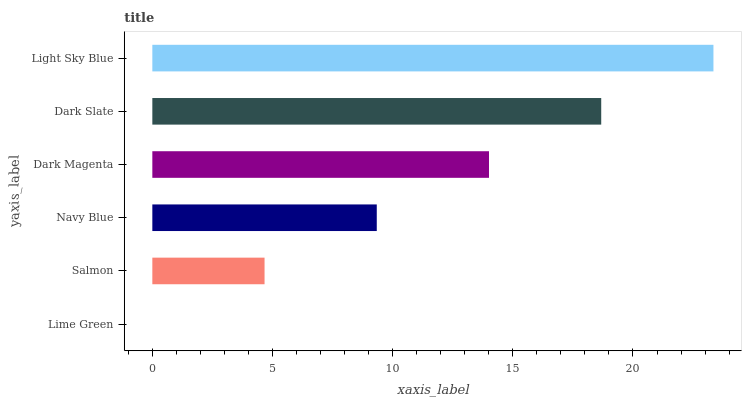Is Lime Green the minimum?
Answer yes or no. Yes. Is Light Sky Blue the maximum?
Answer yes or no. Yes. Is Salmon the minimum?
Answer yes or no. No. Is Salmon the maximum?
Answer yes or no. No. Is Salmon greater than Lime Green?
Answer yes or no. Yes. Is Lime Green less than Salmon?
Answer yes or no. Yes. Is Lime Green greater than Salmon?
Answer yes or no. No. Is Salmon less than Lime Green?
Answer yes or no. No. Is Dark Magenta the high median?
Answer yes or no. Yes. Is Navy Blue the low median?
Answer yes or no. Yes. Is Dark Slate the high median?
Answer yes or no. No. Is Light Sky Blue the low median?
Answer yes or no. No. 